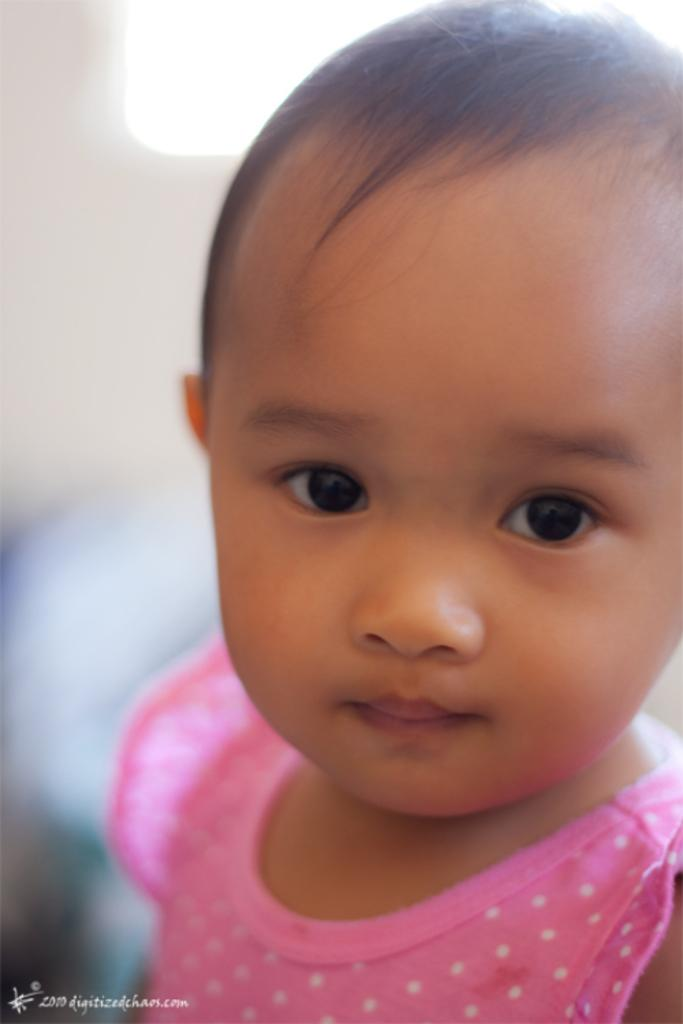Where was the image taken? The image was taken inside a room. Who is present in the image? There is a girl in the image. What color is the background of the image? The background of the image is white. How does the girl fall off the tub in the image? There is no tub present in the image, and the girl is not falling off anything. 